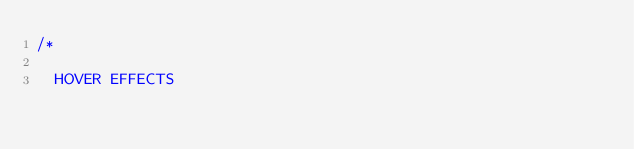Convert code to text. <code><loc_0><loc_0><loc_500><loc_500><_CSS_>/*

  HOVER EFFECTS</code> 